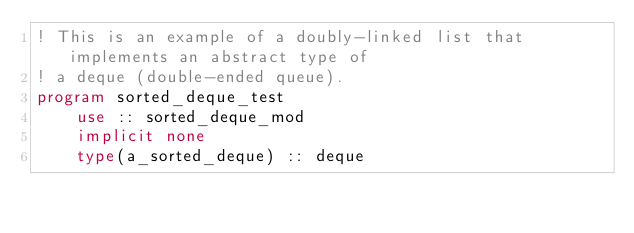Convert code to text. <code><loc_0><loc_0><loc_500><loc_500><_FORTRAN_>! This is an example of a doubly-linked list that implements an abstract type of
! a deque (double-ended queue).
program sorted_deque_test
    use :: sorted_deque_mod
    implicit none
    type(a_sorted_deque) :: deque</code> 